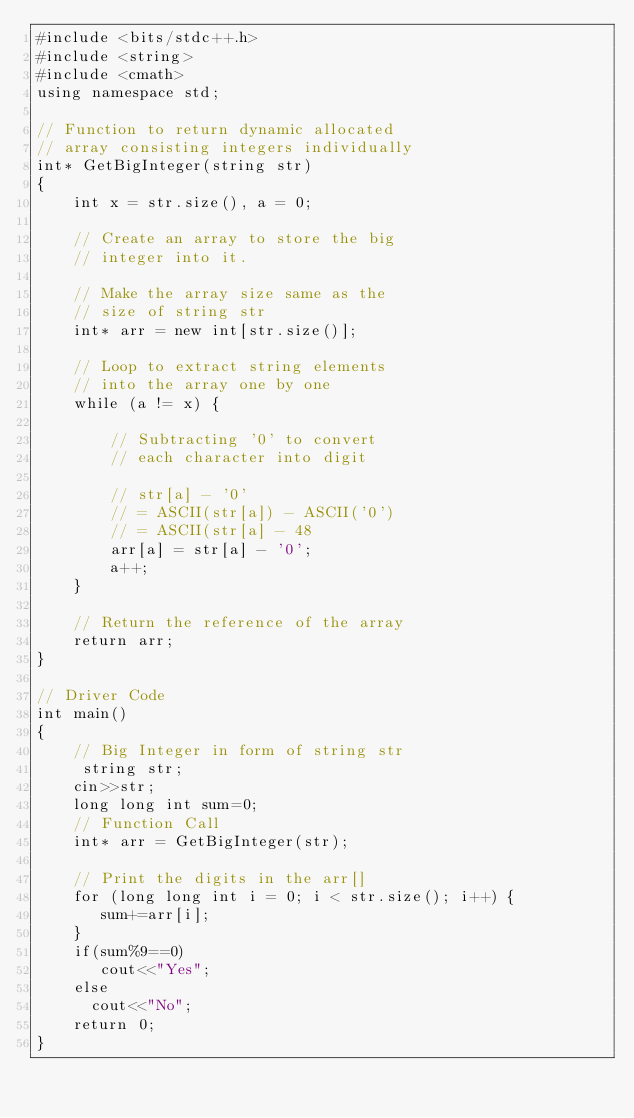Convert code to text. <code><loc_0><loc_0><loc_500><loc_500><_C++_>#include <bits/stdc++.h>
#include <string>
#include <cmath>
using namespace std;
  
// Function to return dynamic allocated 
// array consisting integers individually 
int* GetBigInteger(string str) 
{ 
    int x = str.size(), a = 0; 
  
    // Create an array to store the big 
    // integer into it. 
  
    // Make the array size same as the 
    // size of string str 
    int* arr = new int[str.size()]; 
  
    // Loop to extract string elements 
    // into the array one by one 
    while (a != x) { 
  
        // Subtracting '0' to convert 
        // each character into digit 
  
        // str[a] - '0' 
        // = ASCII(str[a]) - ASCII('0') 
        // = ASCII(str[a] - 48 
        arr[a] = str[a] - '0'; 
        a++; 
    } 
  
    // Return the reference of the array 
    return arr; 
} 
  
// Driver Code 
int main() 
{ 
    // Big Integer in form of string str 
     string str;
    cin>>str;
    long long int sum=0;
    // Function Call 
    int* arr = GetBigInteger(str); 
  
    // Print the digits in the arr[] 
    for (long long int i = 0; i < str.size(); i++) { 
       sum+=arr[i];
    } 
    if(sum%9==0)
       cout<<"Yes";
    else
      cout<<"No"; 
    return 0; 
} 
</code> 